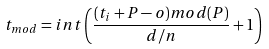Convert formula to latex. <formula><loc_0><loc_0><loc_500><loc_500>t _ { m o d } = i n t \left ( \frac { ( t _ { i } + P - o ) m o d ( P ) } { d / n } + 1 \right )</formula> 